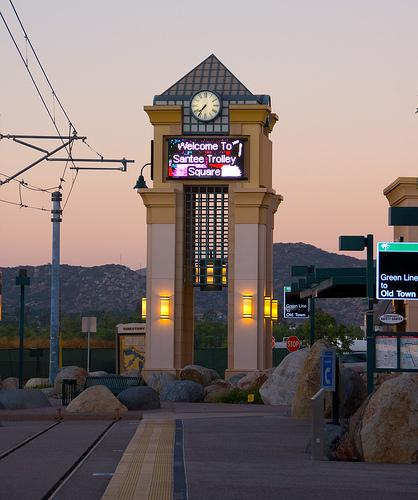Narrate the scene depicted in the image focusing on the time of day. During the evening, a clock tower is lit up along with a payphone, a stop sign, and other elements on the yellow and blue ground. Briefly mention the most eye-catching elements in the image. A clock tower at sunset, a payphone, a stop sign, and a bus sign indicating the green line are all visible in the image. Mention the objects in the image with reference to their positions. Clock tower on top left, bus sign in the middle, stop sign in the center, and payphone slightly below the center. Describe the secondary objects and their locations in relation to the main subject. Adjacent to the clock tower are a stop sign, a payphone, a bus sign indicating a green line, and other minor elements such as utility poles and signage. List down 3 most important objects in the image and their colors. Clock tower (gray), stop sign (red), and metal utility pole (gray). Write a sentence about the most distinctive feature of the image. The image features a clock tower at sunset with an illuminated clock face, standing among various urban elements. Describe the environment in the image, including the ground and sky. The image takes place during the evening, with a sky in the background and a narrow yellow and blue path on the ground. Mention the surrounding elements of the main subject of the image. Clock tower is surrounded by items like an antique clock, a metal utility pole, a bus sign, a pay telephone station, a stop sign, and a large television screen. Create a story out of the objects and interactions visible in the image. As evening approaches in a busy trolley square, people hurry along the narrow paths illuminated by lights while passing by the iconic clock tower and using the payphone located in the area. Write a sentence describing the purpose of the main subject in the image. The clock tower stands tall in the trolley square area, providing timekeeping for the nearby community and serving as an important landmark. 